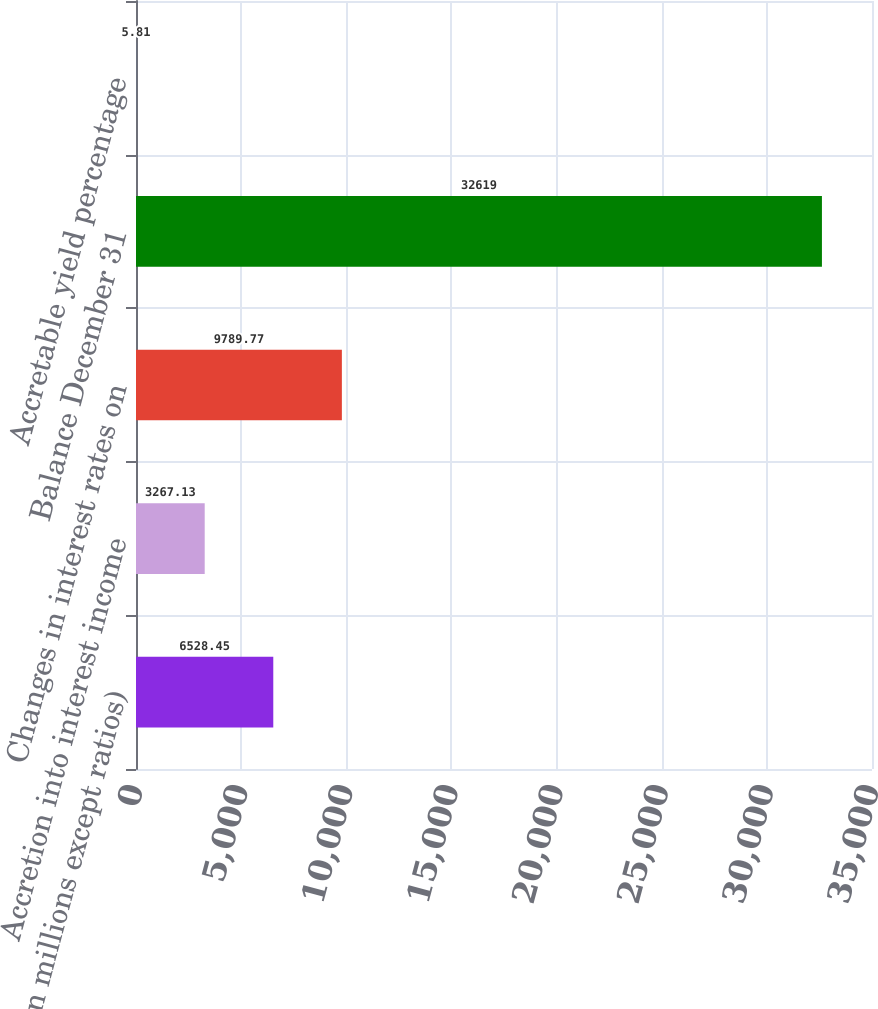<chart> <loc_0><loc_0><loc_500><loc_500><bar_chart><fcel>(in millions except ratios)<fcel>Accretion into interest income<fcel>Changes in interest rates on<fcel>Balance December 31<fcel>Accretable yield percentage<nl><fcel>6528.45<fcel>3267.13<fcel>9789.77<fcel>32619<fcel>5.81<nl></chart> 